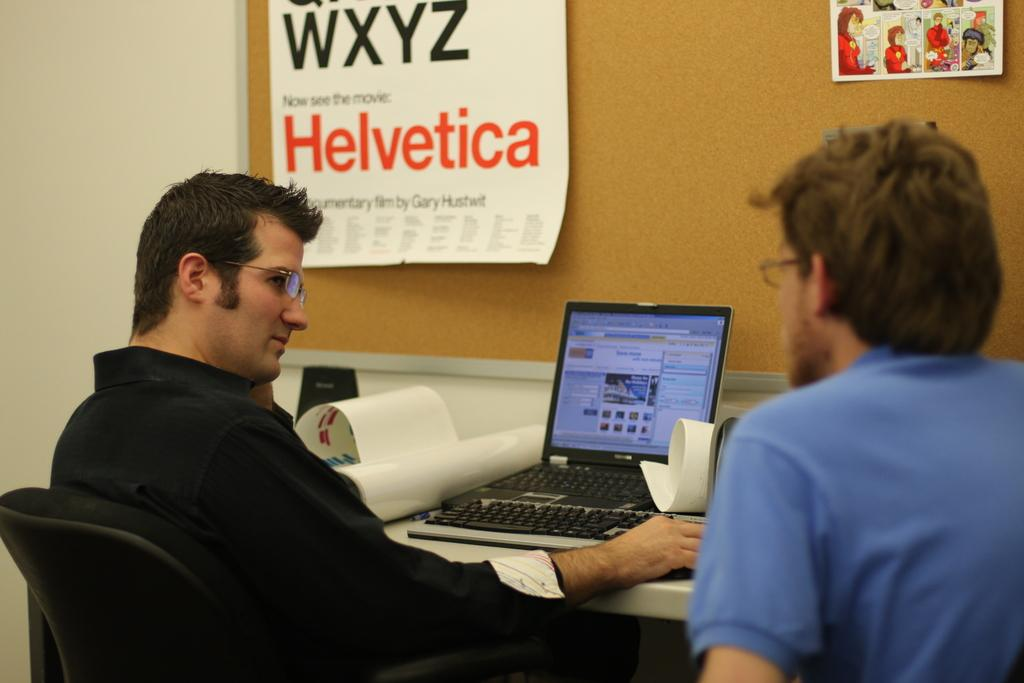Provide a one-sentence caption for the provided image. A poster with "Helvetica" in orange letters hangs on a cork board. 